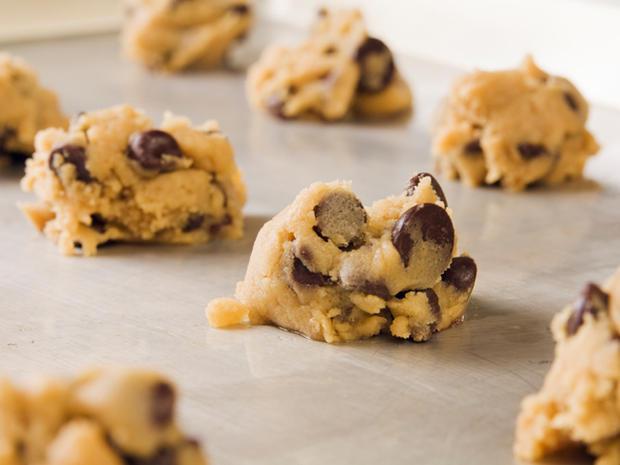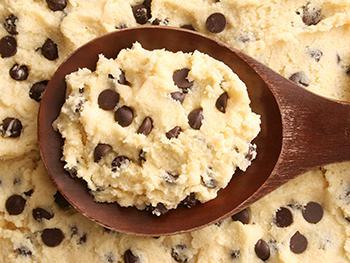The first image is the image on the left, the second image is the image on the right. Assess this claim about the two images: "Someone is using a wooden spoon to make chocolate chip cookies in one of the pictures.". Correct or not? Answer yes or no. Yes. 